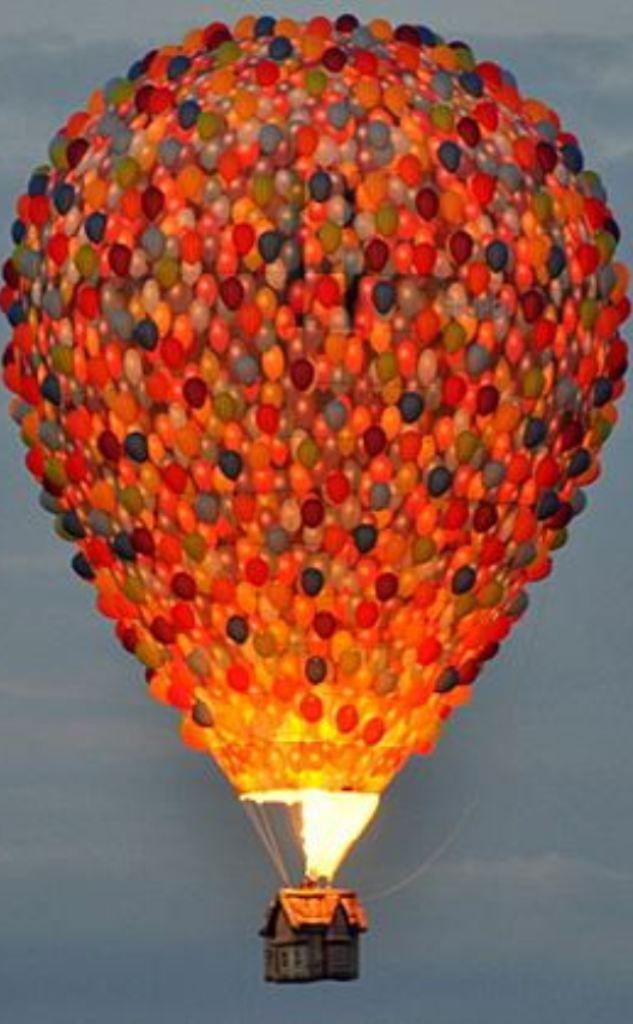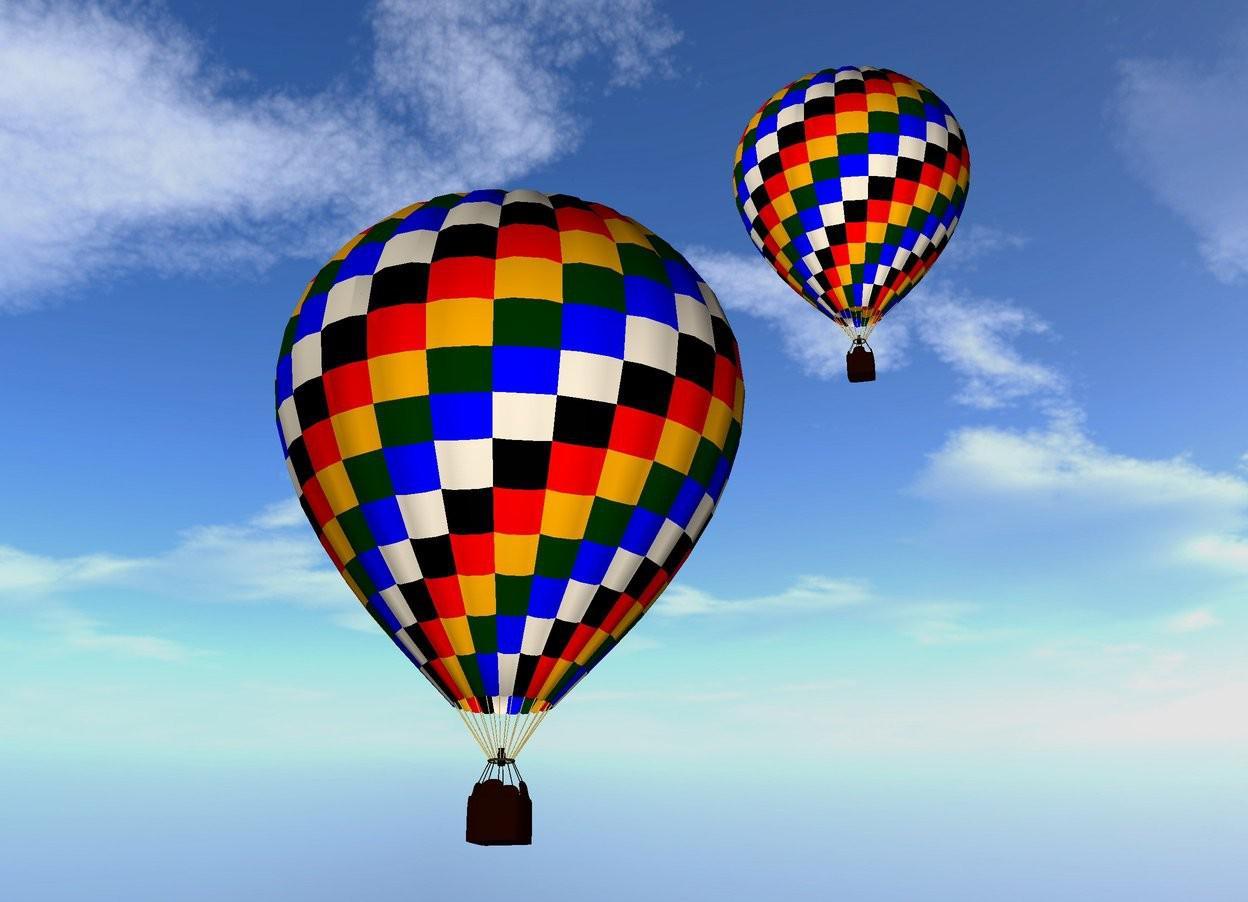The first image is the image on the left, the second image is the image on the right. For the images displayed, is the sentence "Only one image shows a hot air balloon made of many balloons." factually correct? Answer yes or no. Yes. 